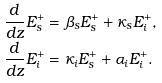<formula> <loc_0><loc_0><loc_500><loc_500>\frac { d } { d z } { E } _ { s } ^ { + } & = \beta _ { s } { E } _ { s } ^ { + } + \kappa _ { s } { E } _ { i } ^ { + } , \\ \frac { d } { d z } { E } _ { i } ^ { + } & = \kappa _ { i } { E } _ { s } ^ { + } + \alpha _ { i } { E } _ { i } ^ { + } .</formula> 